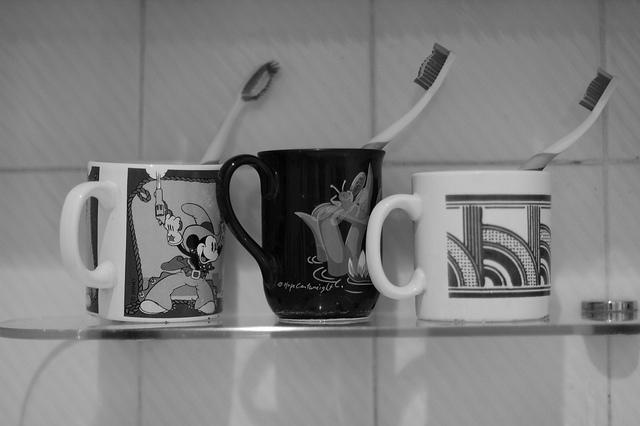What is in the white cup?
Give a very brief answer. Toothbrush. What is in the cup on the right?
Give a very brief answer. Toothbrush. How many people live here?
Keep it brief. 3. What animal shape is this?
Concise answer only. Mouse. Do people usually drink coffee from these mugs?
Quick response, please. No. What is the consistent motif?
Be succinct. Not sure. Is this an appliance?
Be succinct. No. What room of the house would you expect to find this scene in?
Write a very short answer. Bathroom. Is this an expensive blender?
Short answer required. No. 